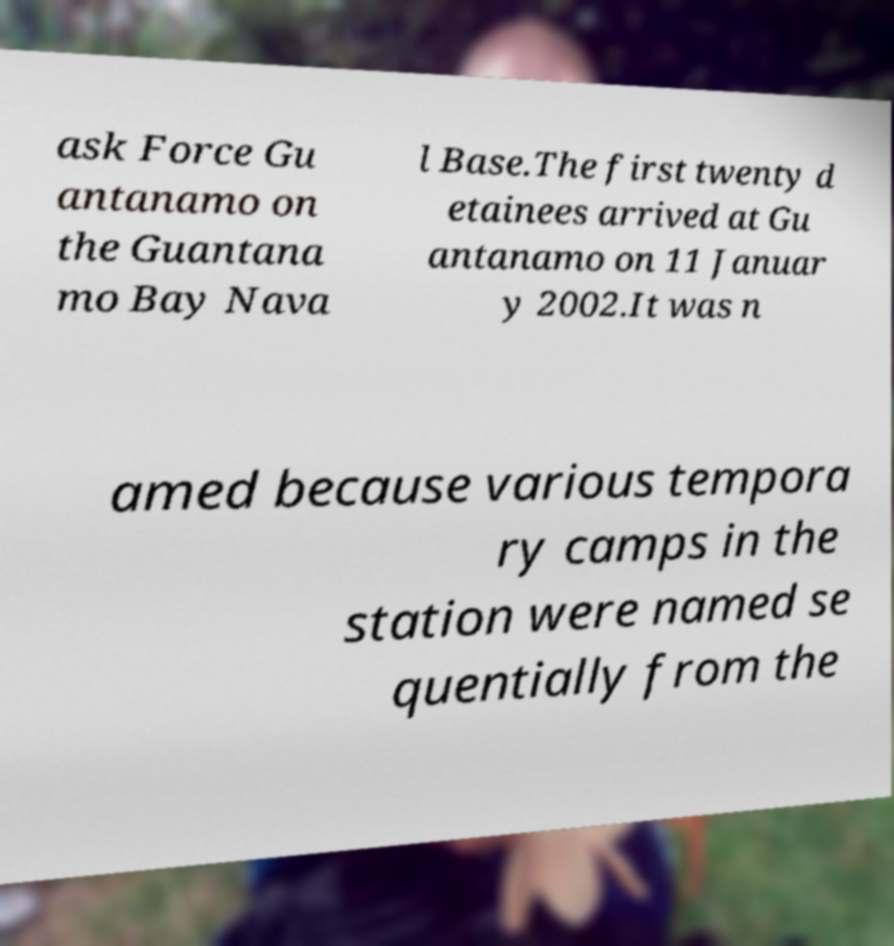Could you assist in decoding the text presented in this image and type it out clearly? ask Force Gu antanamo on the Guantana mo Bay Nava l Base.The first twenty d etainees arrived at Gu antanamo on 11 Januar y 2002.It was n amed because various tempora ry camps in the station were named se quentially from the 